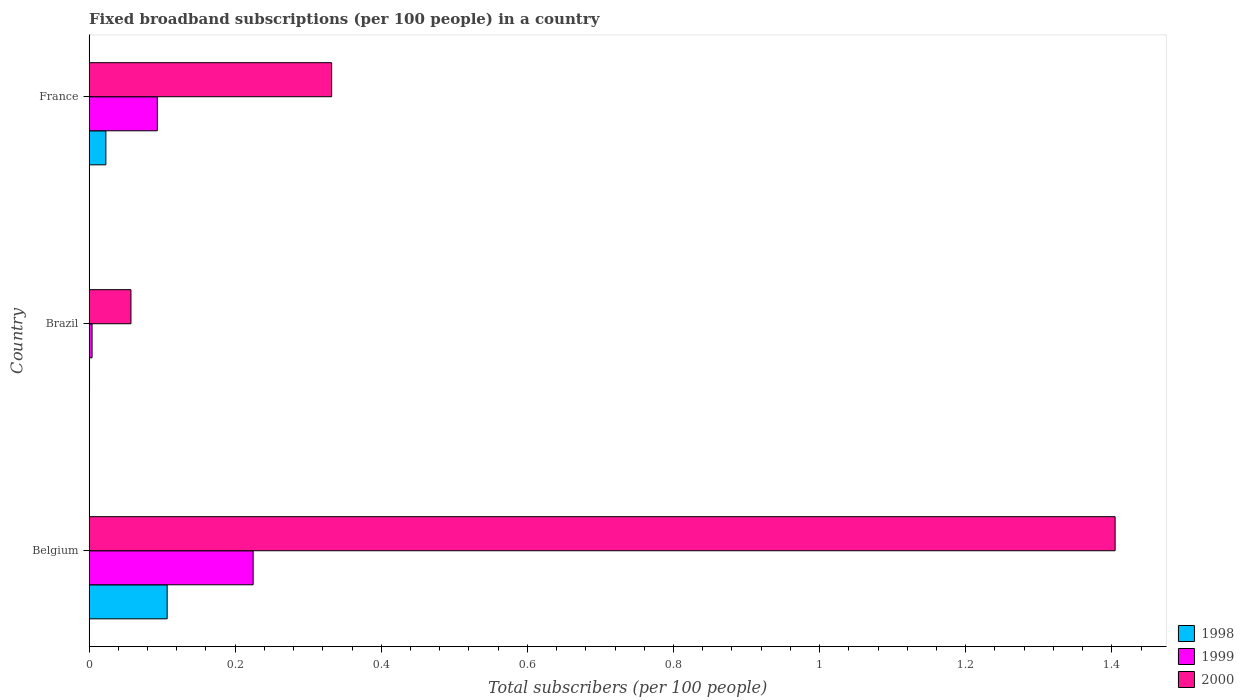How many groups of bars are there?
Give a very brief answer. 3. Are the number of bars per tick equal to the number of legend labels?
Offer a very short reply. Yes. How many bars are there on the 3rd tick from the top?
Offer a terse response. 3. How many bars are there on the 3rd tick from the bottom?
Your answer should be compact. 3. What is the number of broadband subscriptions in 1998 in France?
Ensure brevity in your answer.  0.02. Across all countries, what is the maximum number of broadband subscriptions in 1998?
Make the answer very short. 0.11. Across all countries, what is the minimum number of broadband subscriptions in 1998?
Ensure brevity in your answer.  0. In which country was the number of broadband subscriptions in 1998 minimum?
Offer a very short reply. Brazil. What is the total number of broadband subscriptions in 1999 in the graph?
Ensure brevity in your answer.  0.32. What is the difference between the number of broadband subscriptions in 1999 in Belgium and that in Brazil?
Offer a terse response. 0.22. What is the difference between the number of broadband subscriptions in 1999 in Brazil and the number of broadband subscriptions in 1998 in France?
Offer a very short reply. -0.02. What is the average number of broadband subscriptions in 1999 per country?
Ensure brevity in your answer.  0.11. What is the difference between the number of broadband subscriptions in 2000 and number of broadband subscriptions in 1998 in Brazil?
Keep it short and to the point. 0.06. What is the ratio of the number of broadband subscriptions in 2000 in Brazil to that in France?
Keep it short and to the point. 0.17. Is the number of broadband subscriptions in 1998 in Belgium less than that in Brazil?
Provide a short and direct response. No. Is the difference between the number of broadband subscriptions in 2000 in Belgium and France greater than the difference between the number of broadband subscriptions in 1998 in Belgium and France?
Offer a very short reply. Yes. What is the difference between the highest and the second highest number of broadband subscriptions in 1999?
Offer a terse response. 0.13. What is the difference between the highest and the lowest number of broadband subscriptions in 1998?
Give a very brief answer. 0.11. Is the sum of the number of broadband subscriptions in 1998 in Belgium and France greater than the maximum number of broadband subscriptions in 1999 across all countries?
Your answer should be very brief. No. What does the 2nd bar from the bottom in France represents?
Your answer should be compact. 1999. Is it the case that in every country, the sum of the number of broadband subscriptions in 1999 and number of broadband subscriptions in 1998 is greater than the number of broadband subscriptions in 2000?
Provide a succinct answer. No. Are all the bars in the graph horizontal?
Your answer should be compact. Yes. How many countries are there in the graph?
Make the answer very short. 3. What is the difference between two consecutive major ticks on the X-axis?
Keep it short and to the point. 0.2. Where does the legend appear in the graph?
Make the answer very short. Bottom right. How are the legend labels stacked?
Offer a very short reply. Vertical. What is the title of the graph?
Give a very brief answer. Fixed broadband subscriptions (per 100 people) in a country. Does "1991" appear as one of the legend labels in the graph?
Give a very brief answer. No. What is the label or title of the X-axis?
Your response must be concise. Total subscribers (per 100 people). What is the Total subscribers (per 100 people) of 1998 in Belgium?
Provide a succinct answer. 0.11. What is the Total subscribers (per 100 people) in 1999 in Belgium?
Make the answer very short. 0.22. What is the Total subscribers (per 100 people) of 2000 in Belgium?
Ensure brevity in your answer.  1.4. What is the Total subscribers (per 100 people) in 1998 in Brazil?
Your answer should be very brief. 0. What is the Total subscribers (per 100 people) of 1999 in Brazil?
Keep it short and to the point. 0. What is the Total subscribers (per 100 people) of 2000 in Brazil?
Your answer should be compact. 0.06. What is the Total subscribers (per 100 people) of 1998 in France?
Offer a very short reply. 0.02. What is the Total subscribers (per 100 people) in 1999 in France?
Offer a terse response. 0.09. What is the Total subscribers (per 100 people) of 2000 in France?
Ensure brevity in your answer.  0.33. Across all countries, what is the maximum Total subscribers (per 100 people) in 1998?
Make the answer very short. 0.11. Across all countries, what is the maximum Total subscribers (per 100 people) of 1999?
Your answer should be compact. 0.22. Across all countries, what is the maximum Total subscribers (per 100 people) of 2000?
Offer a terse response. 1.4. Across all countries, what is the minimum Total subscribers (per 100 people) in 1998?
Provide a succinct answer. 0. Across all countries, what is the minimum Total subscribers (per 100 people) in 1999?
Your answer should be compact. 0. Across all countries, what is the minimum Total subscribers (per 100 people) of 2000?
Offer a terse response. 0.06. What is the total Total subscribers (per 100 people) of 1998 in the graph?
Provide a short and direct response. 0.13. What is the total Total subscribers (per 100 people) in 1999 in the graph?
Keep it short and to the point. 0.32. What is the total Total subscribers (per 100 people) of 2000 in the graph?
Provide a succinct answer. 1.79. What is the difference between the Total subscribers (per 100 people) in 1998 in Belgium and that in Brazil?
Make the answer very short. 0.11. What is the difference between the Total subscribers (per 100 people) in 1999 in Belgium and that in Brazil?
Your answer should be very brief. 0.22. What is the difference between the Total subscribers (per 100 people) of 2000 in Belgium and that in Brazil?
Offer a terse response. 1.35. What is the difference between the Total subscribers (per 100 people) of 1998 in Belgium and that in France?
Offer a very short reply. 0.08. What is the difference between the Total subscribers (per 100 people) of 1999 in Belgium and that in France?
Ensure brevity in your answer.  0.13. What is the difference between the Total subscribers (per 100 people) in 2000 in Belgium and that in France?
Provide a short and direct response. 1.07. What is the difference between the Total subscribers (per 100 people) in 1998 in Brazil and that in France?
Ensure brevity in your answer.  -0.02. What is the difference between the Total subscribers (per 100 people) of 1999 in Brazil and that in France?
Offer a very short reply. -0.09. What is the difference between the Total subscribers (per 100 people) of 2000 in Brazil and that in France?
Ensure brevity in your answer.  -0.27. What is the difference between the Total subscribers (per 100 people) in 1998 in Belgium and the Total subscribers (per 100 people) in 1999 in Brazil?
Provide a succinct answer. 0.1. What is the difference between the Total subscribers (per 100 people) in 1998 in Belgium and the Total subscribers (per 100 people) in 2000 in Brazil?
Provide a short and direct response. 0.05. What is the difference between the Total subscribers (per 100 people) in 1999 in Belgium and the Total subscribers (per 100 people) in 2000 in Brazil?
Offer a very short reply. 0.17. What is the difference between the Total subscribers (per 100 people) of 1998 in Belgium and the Total subscribers (per 100 people) of 1999 in France?
Ensure brevity in your answer.  0.01. What is the difference between the Total subscribers (per 100 people) in 1998 in Belgium and the Total subscribers (per 100 people) in 2000 in France?
Your answer should be very brief. -0.23. What is the difference between the Total subscribers (per 100 people) in 1999 in Belgium and the Total subscribers (per 100 people) in 2000 in France?
Give a very brief answer. -0.11. What is the difference between the Total subscribers (per 100 people) in 1998 in Brazil and the Total subscribers (per 100 people) in 1999 in France?
Ensure brevity in your answer.  -0.09. What is the difference between the Total subscribers (per 100 people) of 1998 in Brazil and the Total subscribers (per 100 people) of 2000 in France?
Ensure brevity in your answer.  -0.33. What is the difference between the Total subscribers (per 100 people) of 1999 in Brazil and the Total subscribers (per 100 people) of 2000 in France?
Give a very brief answer. -0.33. What is the average Total subscribers (per 100 people) in 1998 per country?
Your answer should be compact. 0.04. What is the average Total subscribers (per 100 people) of 1999 per country?
Offer a very short reply. 0.11. What is the average Total subscribers (per 100 people) in 2000 per country?
Keep it short and to the point. 0.6. What is the difference between the Total subscribers (per 100 people) in 1998 and Total subscribers (per 100 people) in 1999 in Belgium?
Keep it short and to the point. -0.12. What is the difference between the Total subscribers (per 100 people) in 1998 and Total subscribers (per 100 people) in 2000 in Belgium?
Provide a succinct answer. -1.3. What is the difference between the Total subscribers (per 100 people) of 1999 and Total subscribers (per 100 people) of 2000 in Belgium?
Provide a short and direct response. -1.18. What is the difference between the Total subscribers (per 100 people) of 1998 and Total subscribers (per 100 people) of 1999 in Brazil?
Ensure brevity in your answer.  -0. What is the difference between the Total subscribers (per 100 people) in 1998 and Total subscribers (per 100 people) in 2000 in Brazil?
Offer a terse response. -0.06. What is the difference between the Total subscribers (per 100 people) of 1999 and Total subscribers (per 100 people) of 2000 in Brazil?
Offer a terse response. -0.05. What is the difference between the Total subscribers (per 100 people) of 1998 and Total subscribers (per 100 people) of 1999 in France?
Keep it short and to the point. -0.07. What is the difference between the Total subscribers (per 100 people) in 1998 and Total subscribers (per 100 people) in 2000 in France?
Keep it short and to the point. -0.31. What is the difference between the Total subscribers (per 100 people) of 1999 and Total subscribers (per 100 people) of 2000 in France?
Ensure brevity in your answer.  -0.24. What is the ratio of the Total subscribers (per 100 people) in 1998 in Belgium to that in Brazil?
Your answer should be very brief. 181.1. What is the ratio of the Total subscribers (per 100 people) of 1999 in Belgium to that in Brazil?
Give a very brief answer. 55.18. What is the ratio of the Total subscribers (per 100 people) in 2000 in Belgium to that in Brazil?
Offer a terse response. 24.51. What is the ratio of the Total subscribers (per 100 people) of 1998 in Belgium to that in France?
Make the answer very short. 4.65. What is the ratio of the Total subscribers (per 100 people) of 1999 in Belgium to that in France?
Make the answer very short. 2.4. What is the ratio of the Total subscribers (per 100 people) in 2000 in Belgium to that in France?
Your answer should be very brief. 4.23. What is the ratio of the Total subscribers (per 100 people) of 1998 in Brazil to that in France?
Give a very brief answer. 0.03. What is the ratio of the Total subscribers (per 100 people) in 1999 in Brazil to that in France?
Your answer should be compact. 0.04. What is the ratio of the Total subscribers (per 100 people) in 2000 in Brazil to that in France?
Your answer should be very brief. 0.17. What is the difference between the highest and the second highest Total subscribers (per 100 people) of 1998?
Offer a very short reply. 0.08. What is the difference between the highest and the second highest Total subscribers (per 100 people) of 1999?
Make the answer very short. 0.13. What is the difference between the highest and the second highest Total subscribers (per 100 people) of 2000?
Your answer should be compact. 1.07. What is the difference between the highest and the lowest Total subscribers (per 100 people) of 1998?
Give a very brief answer. 0.11. What is the difference between the highest and the lowest Total subscribers (per 100 people) of 1999?
Ensure brevity in your answer.  0.22. What is the difference between the highest and the lowest Total subscribers (per 100 people) of 2000?
Provide a short and direct response. 1.35. 